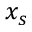<formula> <loc_0><loc_0><loc_500><loc_500>x _ { s }</formula> 